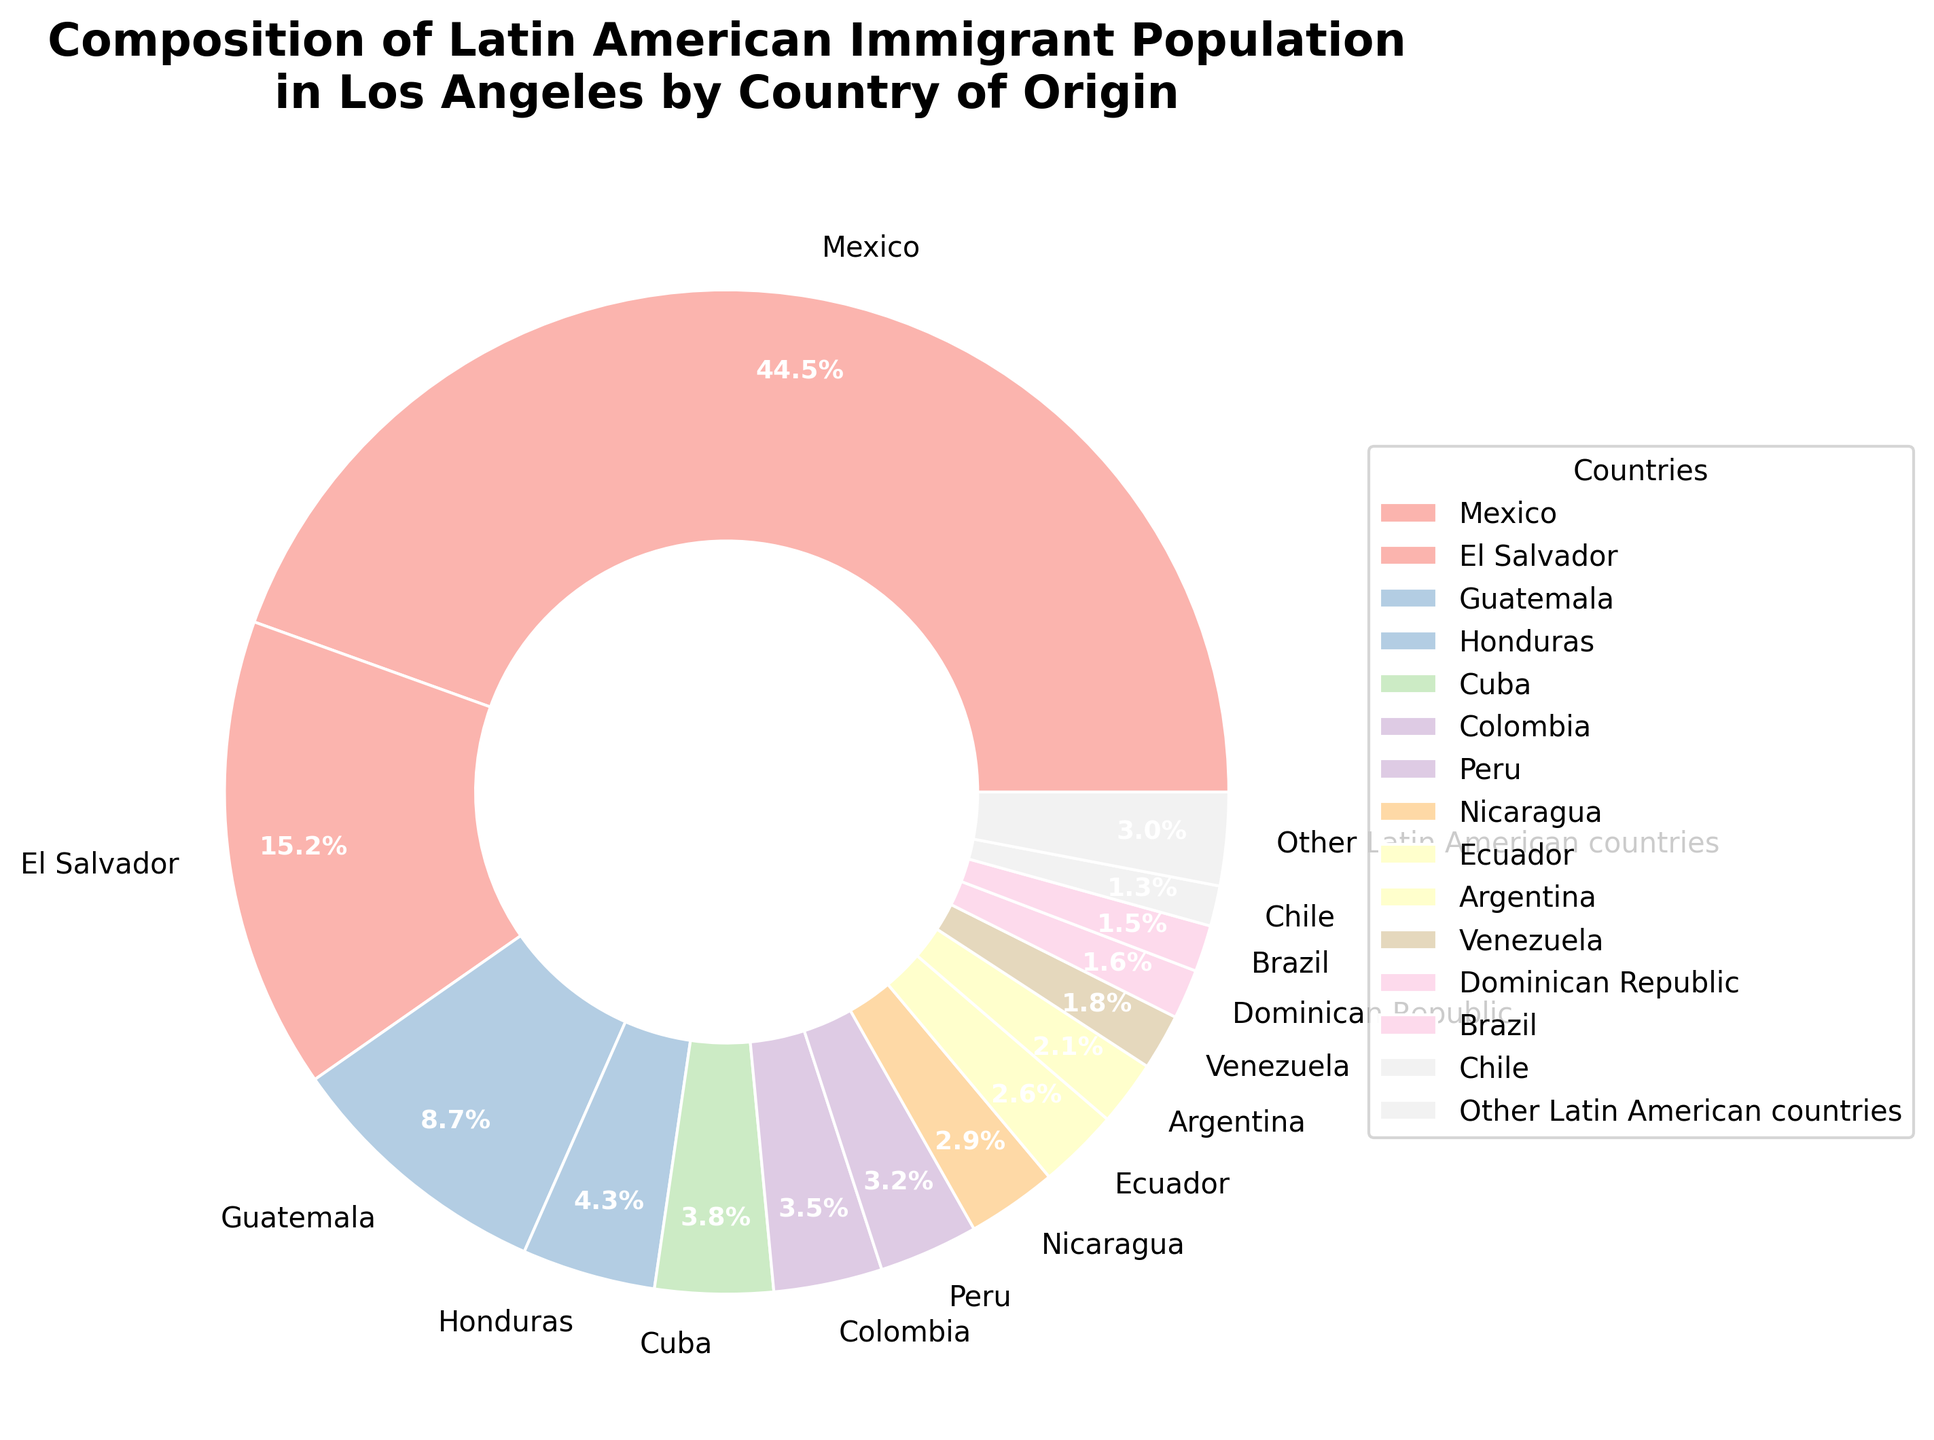What percentage of the Latin American immigrant population in Los Angeles is from Mexico? The figure shows a pie chart with different countries represented in the population. According to the chart, the percentage of the population from Mexico is labeled.
Answer: 44.5% Which country has the second-highest percentage of Latin American immigrants in Los Angeles? The figure shows a pie chart that lists all the countries by their percentage. The second-highest percentage after Mexico's 44.5% is El Salvador with 15.2%.
Answer: El Salvador Is the combined percentage of the Latin American immigrant population from Honduras and Cuba higher or lower than 10%? To answer this, add the percentages for Honduras and Cuba (4.3% + 3.8% = 8.1%) and then compare it to 10%. The combined percentage is lower than 10%.
Answer: Lower Which countries in the pie chart together contribute to a 6.4% share of the immigrant population? Check the segments of the pie chart and their percentages. Colombia (3.5%) and Peru (3.2%) together contribute 6.7%, which is closest to the given number without exceeding it.
Answer: Colombia and Peru What is the total percentage of the immigrant population from Guatemala, Nicaragua, and Ecuador? Add the percentages for Guatemala (8.7%), Nicaragua (2.9%), and Ecuador (2.6%). The total is 8.7 + 2.9 + 2.6 = 14.2%.
Answer: 14.2% Which country has the smallest percentage among the listed countries in the chart? Look at the pie chart and locate the country with the smallest segment. Brazil, with 1.5%, is the smallest.
Answer: Brazil How does the percentage of immigrants from Venezuela compare to that from Argentina? Look at the pie chart. Venezuela has 1.8%, and Argentina has 2.1%. Comparing the two, Venezuela's percentage is smaller than Argentina's.
Answer: Smaller What is the sum of the percentages of the top three countries? Identify the top three countries by their percentages: Mexico (44.5%), El Salvador (15.2%), and Guatemala (8.7%). Add their percentages: 44.5 + 15.2 + 8.7 = 68.4%.
Answer: 68.4% What is the difference in population percentages between Cuba and Nicaragua? According to the pie chart, Cuba has a percentage of 3.8%, and Nicaragua has 2.9%. Subtract the smaller percentage from the larger one: 3.8 - 2.9 = 0.9%.
Answer: 0.9% What is the visual attribute used to differentiate the countries in the pie chart? The pie chart uses different colors to represent each country, making it easier to distinguish between them visually.
Answer: Colors 